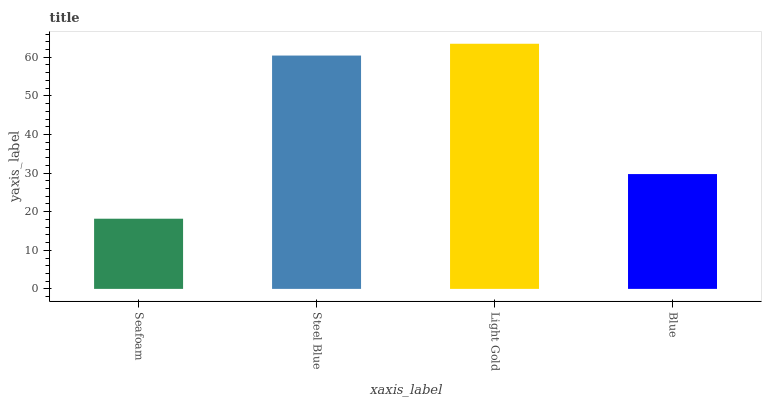Is Steel Blue the minimum?
Answer yes or no. No. Is Steel Blue the maximum?
Answer yes or no. No. Is Steel Blue greater than Seafoam?
Answer yes or no. Yes. Is Seafoam less than Steel Blue?
Answer yes or no. Yes. Is Seafoam greater than Steel Blue?
Answer yes or no. No. Is Steel Blue less than Seafoam?
Answer yes or no. No. Is Steel Blue the high median?
Answer yes or no. Yes. Is Blue the low median?
Answer yes or no. Yes. Is Seafoam the high median?
Answer yes or no. No. Is Seafoam the low median?
Answer yes or no. No. 